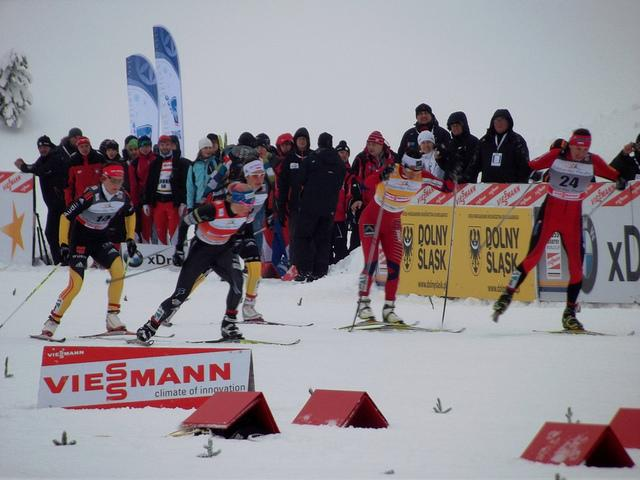What country does the sponsor closest to the camera have it's headquarters located?

Choices:
A) israel
B) ukraine
C) germany
D) poland germany 